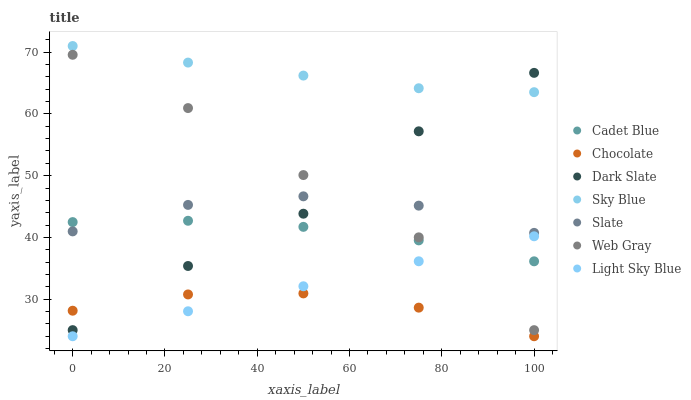Does Chocolate have the minimum area under the curve?
Answer yes or no. Yes. Does Sky Blue have the maximum area under the curve?
Answer yes or no. Yes. Does Slate have the minimum area under the curve?
Answer yes or no. No. Does Slate have the maximum area under the curve?
Answer yes or no. No. Is Light Sky Blue the smoothest?
Answer yes or no. Yes. Is Dark Slate the roughest?
Answer yes or no. Yes. Is Slate the smoothest?
Answer yes or no. No. Is Slate the roughest?
Answer yes or no. No. Does Chocolate have the lowest value?
Answer yes or no. Yes. Does Slate have the lowest value?
Answer yes or no. No. Does Sky Blue have the highest value?
Answer yes or no. Yes. Does Slate have the highest value?
Answer yes or no. No. Is Slate less than Sky Blue?
Answer yes or no. Yes. Is Slate greater than Light Sky Blue?
Answer yes or no. Yes. Does Slate intersect Cadet Blue?
Answer yes or no. Yes. Is Slate less than Cadet Blue?
Answer yes or no. No. Is Slate greater than Cadet Blue?
Answer yes or no. No. Does Slate intersect Sky Blue?
Answer yes or no. No. 